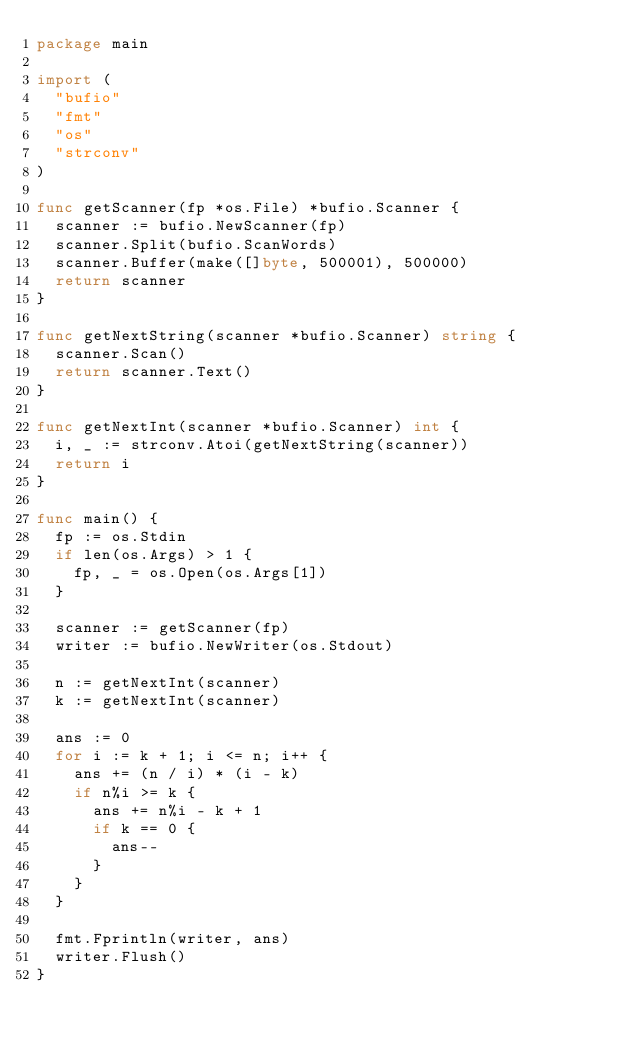Convert code to text. <code><loc_0><loc_0><loc_500><loc_500><_Go_>package main

import (
	"bufio"
	"fmt"
	"os"
	"strconv"
)

func getScanner(fp *os.File) *bufio.Scanner {
	scanner := bufio.NewScanner(fp)
	scanner.Split(bufio.ScanWords)
	scanner.Buffer(make([]byte, 500001), 500000)
	return scanner
}

func getNextString(scanner *bufio.Scanner) string {
	scanner.Scan()
	return scanner.Text()
}

func getNextInt(scanner *bufio.Scanner) int {
	i, _ := strconv.Atoi(getNextString(scanner))
	return i
}

func main() {
	fp := os.Stdin
	if len(os.Args) > 1 {
		fp, _ = os.Open(os.Args[1])
	}

	scanner := getScanner(fp)
	writer := bufio.NewWriter(os.Stdout)

	n := getNextInt(scanner)
	k := getNextInt(scanner)

	ans := 0
	for i := k + 1; i <= n; i++ {
		ans += (n / i) * (i - k)
		if n%i >= k {
			ans += n%i - k + 1
			if k == 0 {
				ans--
			}
		}
	}

	fmt.Fprintln(writer, ans)
	writer.Flush()
}
</code> 